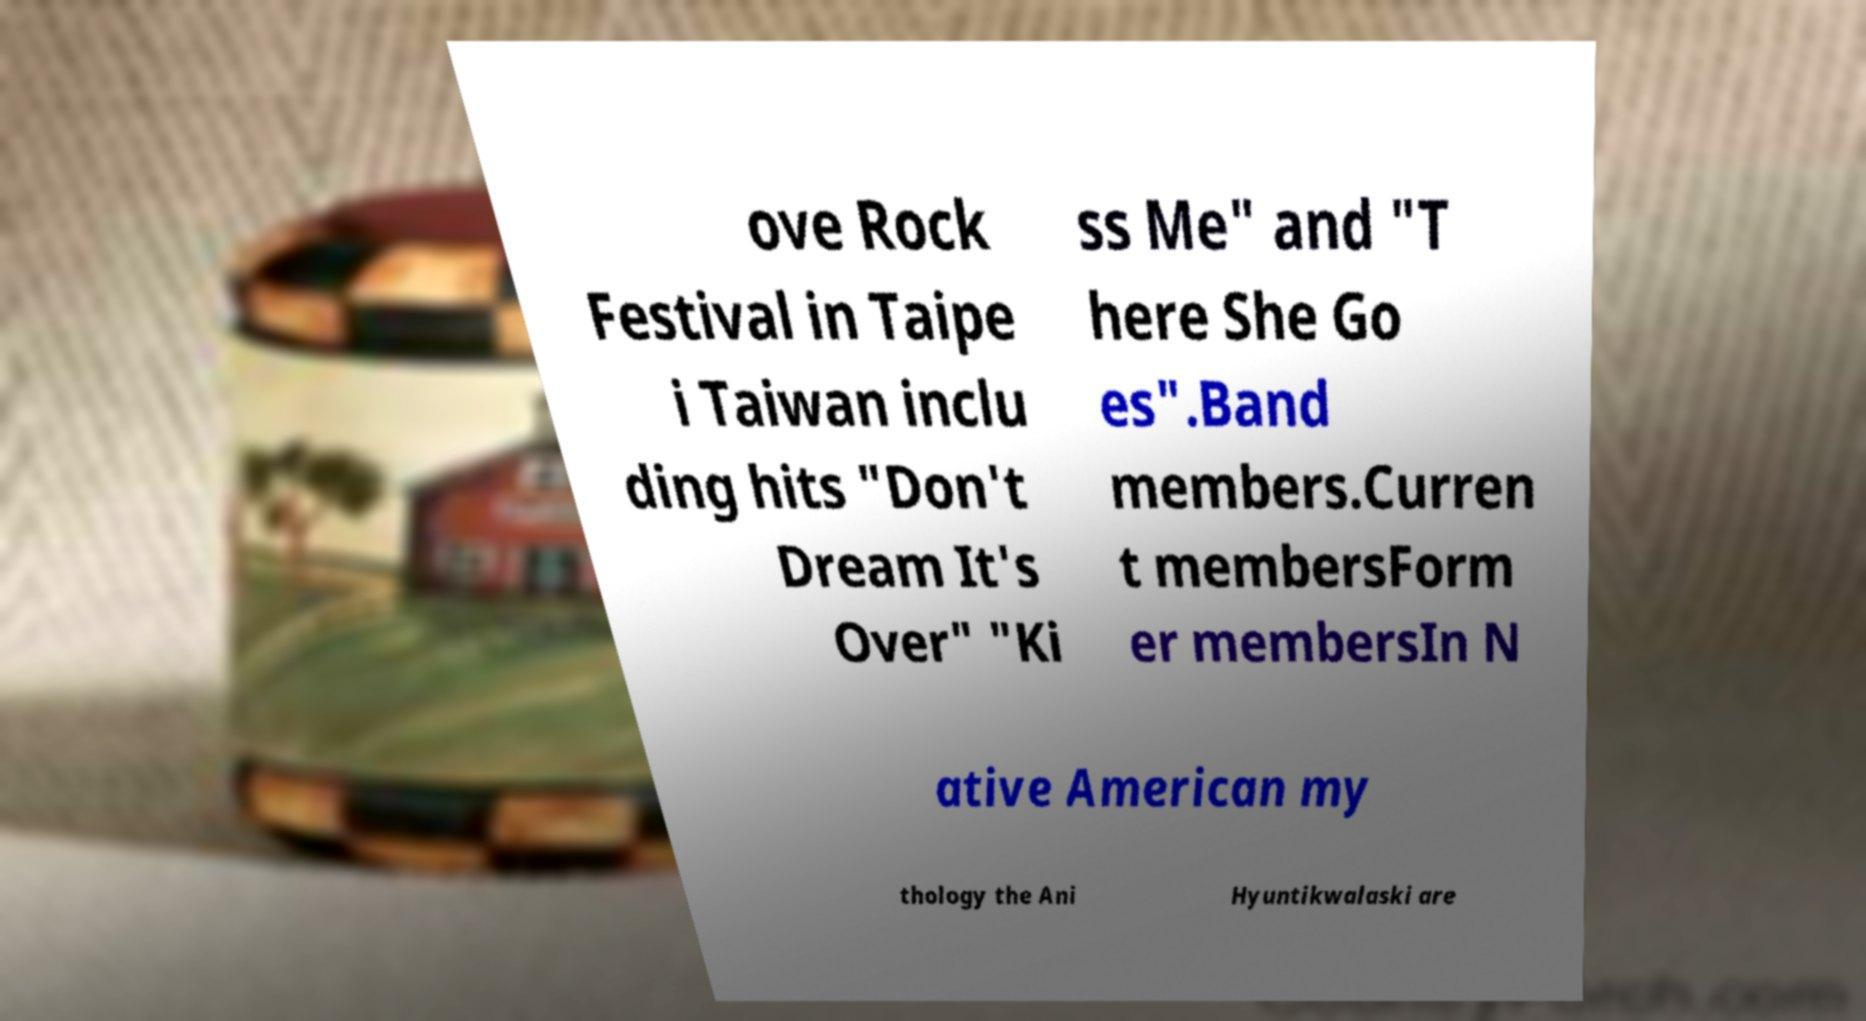Please identify and transcribe the text found in this image. ove Rock Festival in Taipe i Taiwan inclu ding hits "Don't Dream It's Over" "Ki ss Me" and "T here She Go es".Band members.Curren t membersForm er membersIn N ative American my thology the Ani Hyuntikwalaski are 